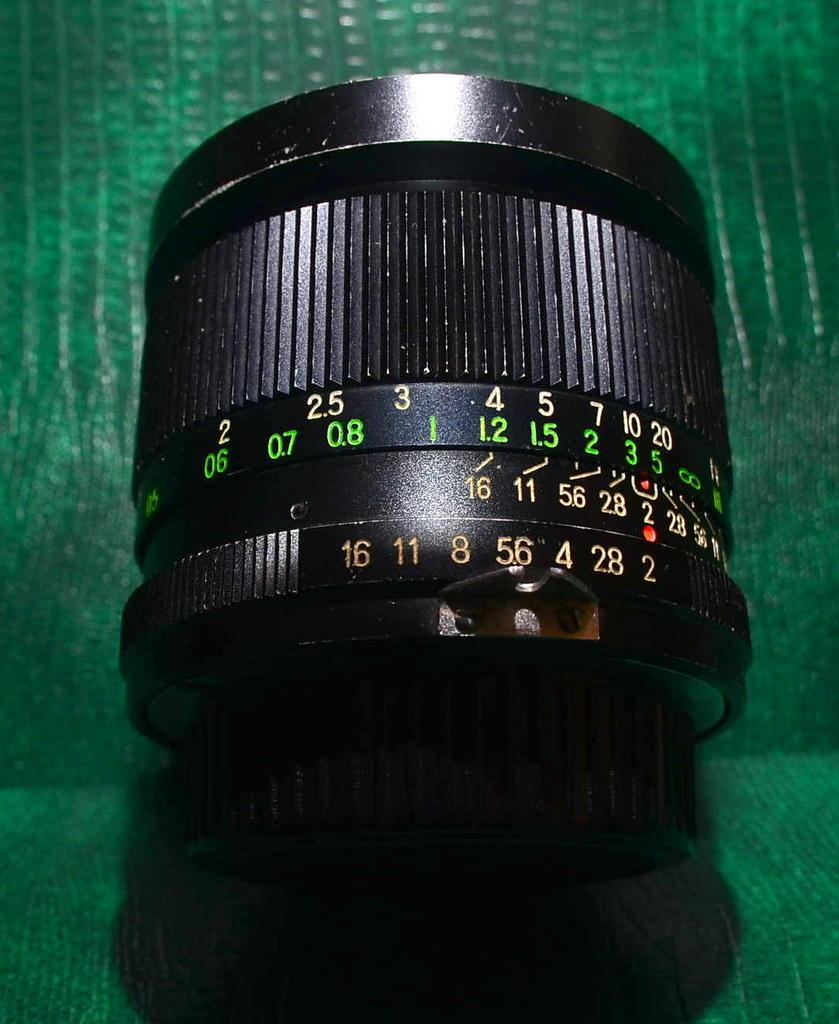What is the main subject of the image? The main subject of the image is a black camera lens. Are there any markings or details on the camera lens? Yes, there are numbers written on the camera lens. What can be seen in the background of the image? There is a green object in the background of the image. What type of fowl can be seen sitting on the camera lens in the image? There is no fowl present on the camera lens in the image. Is the green object in the background made of plastic? The provided facts do not mention the material of the green object, so we cannot determine if it is made of plastic or not. 